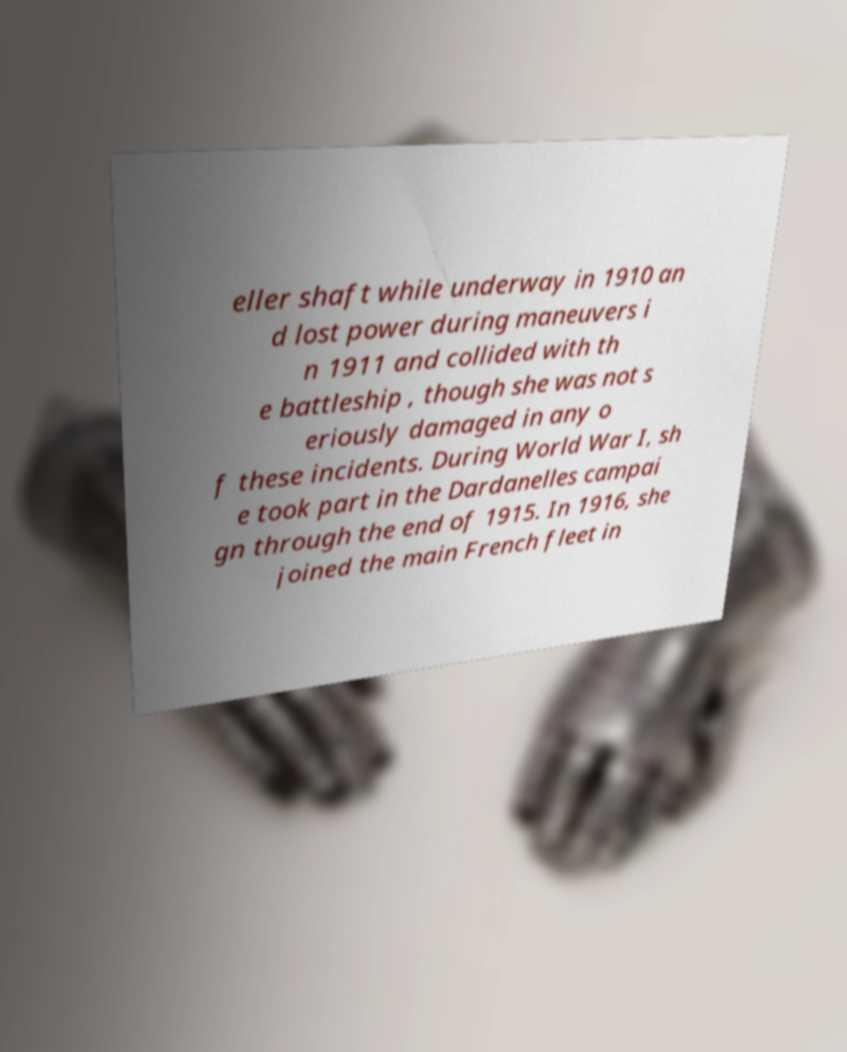Could you assist in decoding the text presented in this image and type it out clearly? eller shaft while underway in 1910 an d lost power during maneuvers i n 1911 and collided with th e battleship , though she was not s eriously damaged in any o f these incidents. During World War I, sh e took part in the Dardanelles campai gn through the end of 1915. In 1916, she joined the main French fleet in 